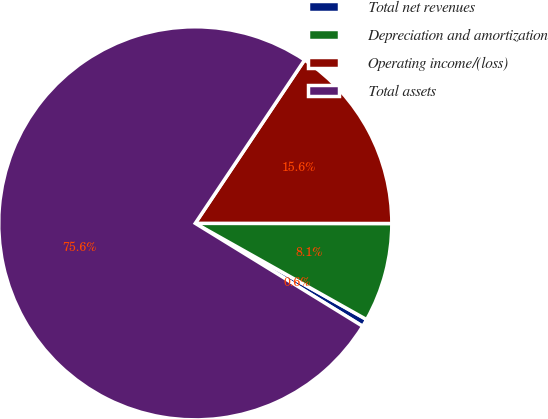Convert chart. <chart><loc_0><loc_0><loc_500><loc_500><pie_chart><fcel>Total net revenues<fcel>Depreciation and amortization<fcel>Operating income/(loss)<fcel>Total assets<nl><fcel>0.63%<fcel>8.13%<fcel>15.63%<fcel>75.61%<nl></chart> 